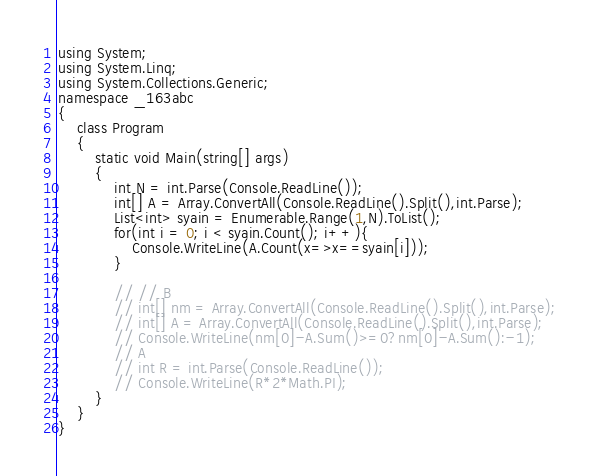Convert code to text. <code><loc_0><loc_0><loc_500><loc_500><_C#_>using System;
using System.Linq;
using System.Collections.Generic;
namespace _163abc
{
    class Program
    {
        static void Main(string[] args)
        {
            int N = int.Parse(Console.ReadLine());
            int[] A = Array.ConvertAll(Console.ReadLine().Split(),int.Parse);
            List<int> syain = Enumerable.Range(1,N).ToList();
            for(int i = 0; i < syain.Count(); i++){
                Console.WriteLine(A.Count(x=>x==syain[i]));
            }

            // // B
            // int[] nm = Array.ConvertAll(Console.ReadLine().Split(),int.Parse);
            // int[] A = Array.ConvertAll(Console.ReadLine().Split(),int.Parse);
            // Console.WriteLine(nm[0]-A.Sum()>=0?nm[0]-A.Sum():-1);
            // A
            // int R = int.Parse(Console.ReadLine());
            // Console.WriteLine(R*2*Math.PI);
        }
    }
}</code> 